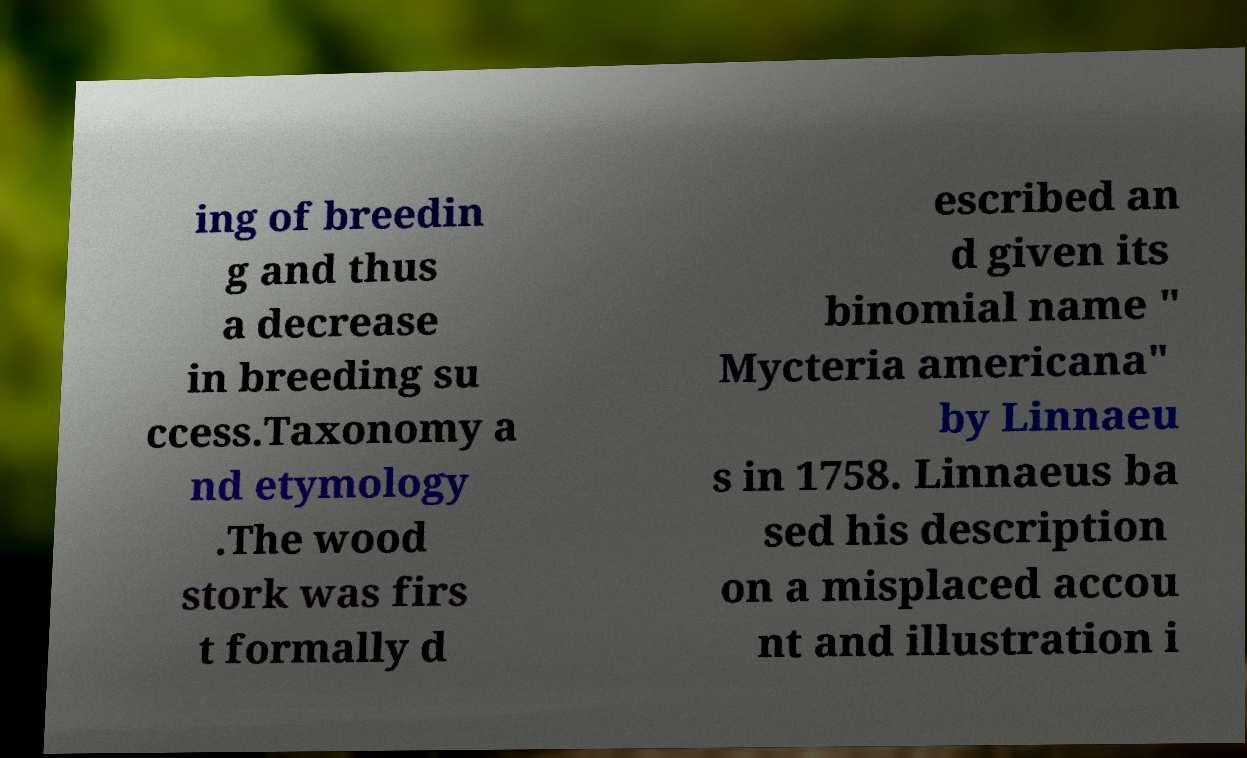Could you assist in decoding the text presented in this image and type it out clearly? ing of breedin g and thus a decrease in breeding su ccess.Taxonomy a nd etymology .The wood stork was firs t formally d escribed an d given its binomial name " Mycteria americana" by Linnaeu s in 1758. Linnaeus ba sed his description on a misplaced accou nt and illustration i 